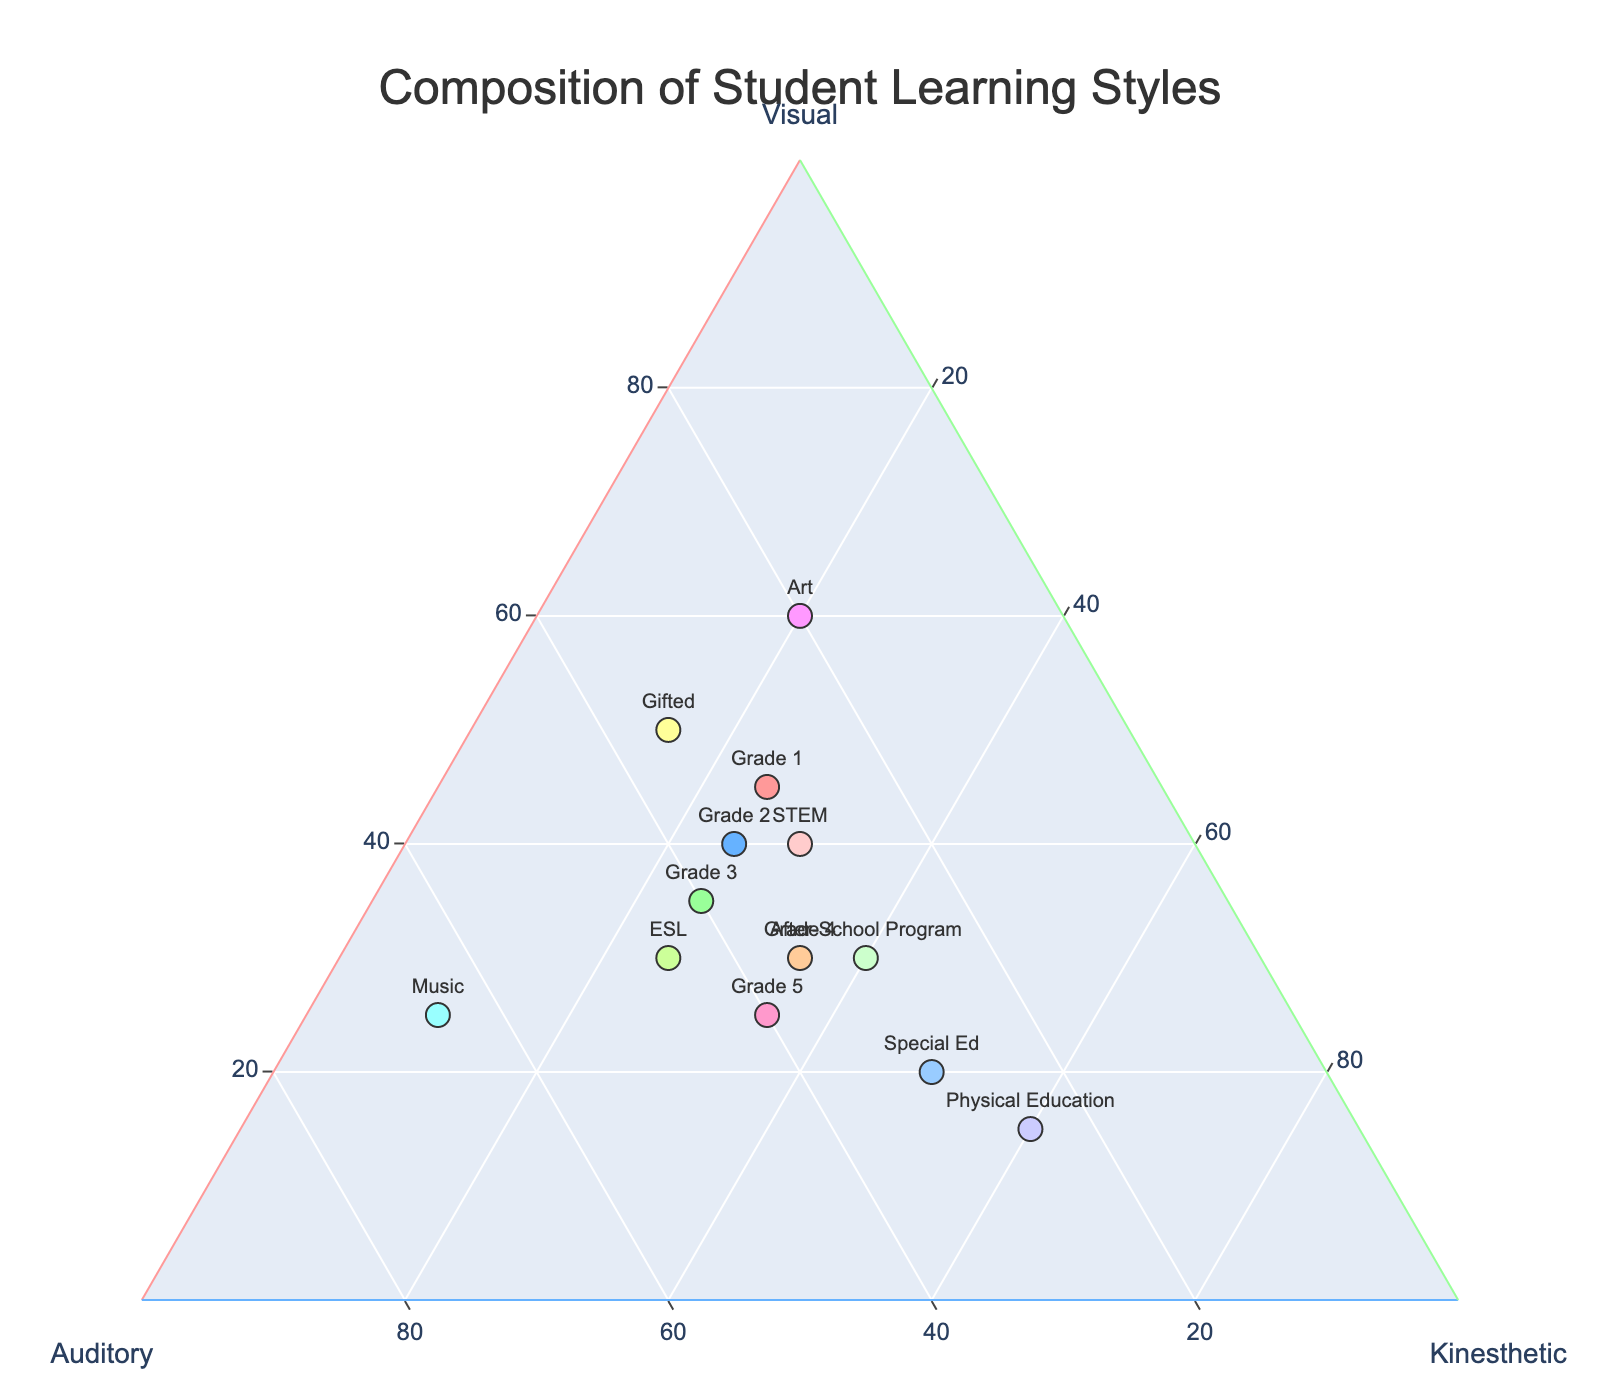what is the title of the plot? The title is displayed at the top center of the plot. It reads "Composition of Student Learning Styles".
Answer: Composition of Student Learning Styles How many classes are represented in the plot? Each class is marked by a unique color and label in the plot. There are 13 different classes listed.
Answer: 13 Which class has the highest percentage of kinesthetic learners? Look for the class positioned nearest to the 'Kinesthetic' corner of the ternary plot. Physical Education is closest, indicating the highest percentage of kinesthetic learners.
Answer: Physical Education How does the proportion of visual learners in Grade 5 compare to that in Gifted class? Locate the positions of Grade 5 and Gifted class. Grade 5 is closer to the 'Visual' axis compared to Gifted, indicating a lower proportion of visual learners in Grade 5.
Answer: Grade 5 has a lower proportion Which class has an equal distribution of visual and auditory learners? Find the class closest to the midpoint between the 'Visual' and 'Auditory' axes. Grade 3 appears to be equally distributed between visual and auditory learners.
Answer: Grade 3 Which two classes share the same percentage of visual learners but differ in auditory and kinesthetic percentages? Check the classes aligning vertically under the same 'Visual' axis line. Grade 2 and STEM both have 40% visual learners but differ in auditory and kinesthetic proportions.
Answer: Grade 2 and STEM What is the total percentage of visual learners for the Art and Gifted classes combined? Add the visual percentages for Art (60%) and Gifted (50%) classes. 60 + 50 = 110.
Answer: 110% Which class has the highest auditory learners and where is it positioned in the plot? Identify the class closest to the 'Auditory' corner. Music has the highest auditory learners and is located near the bottom left corner of the plot.
Answer: Music, bottom left What is the combined percentage of auditory and kinesthetic learners in the After-School Program? Sum the auditory (30%) and kinesthetic (40%) percentages for the After-School Program. 30 + 40 = 70.
Answer: 70% How does the distribution of learning styles in Special Ed compare to ESL? Compare positions of Special Ed and ESL. Special Ed has a notably higher percentage of kinesthetic learners and lower visual learners compared to ESL.
Answer: Special Ed has more kinesthetic, fewer visual 